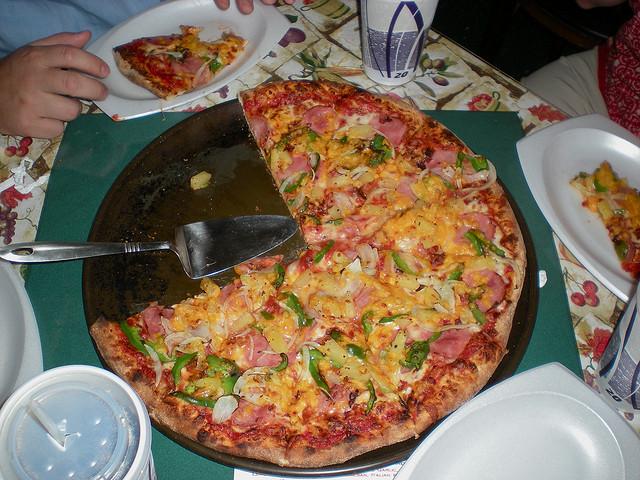Is the pizza cooked with rice?
Short answer required. No. Is this a ham pizza?
Be succinct. Yes. Is this a whole pizza?
Give a very brief answer. No. 